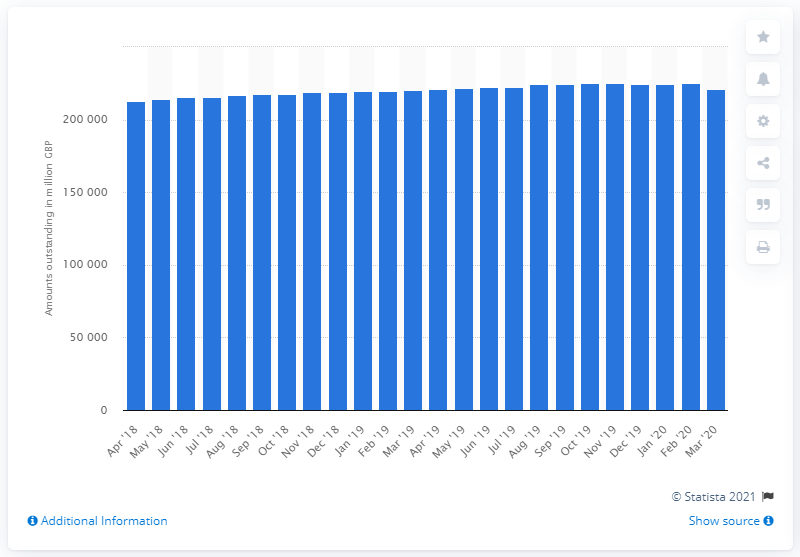Draw attention to some important aspects in this diagram. In February 2020, the value of consumer credit was approximately 225,247. 